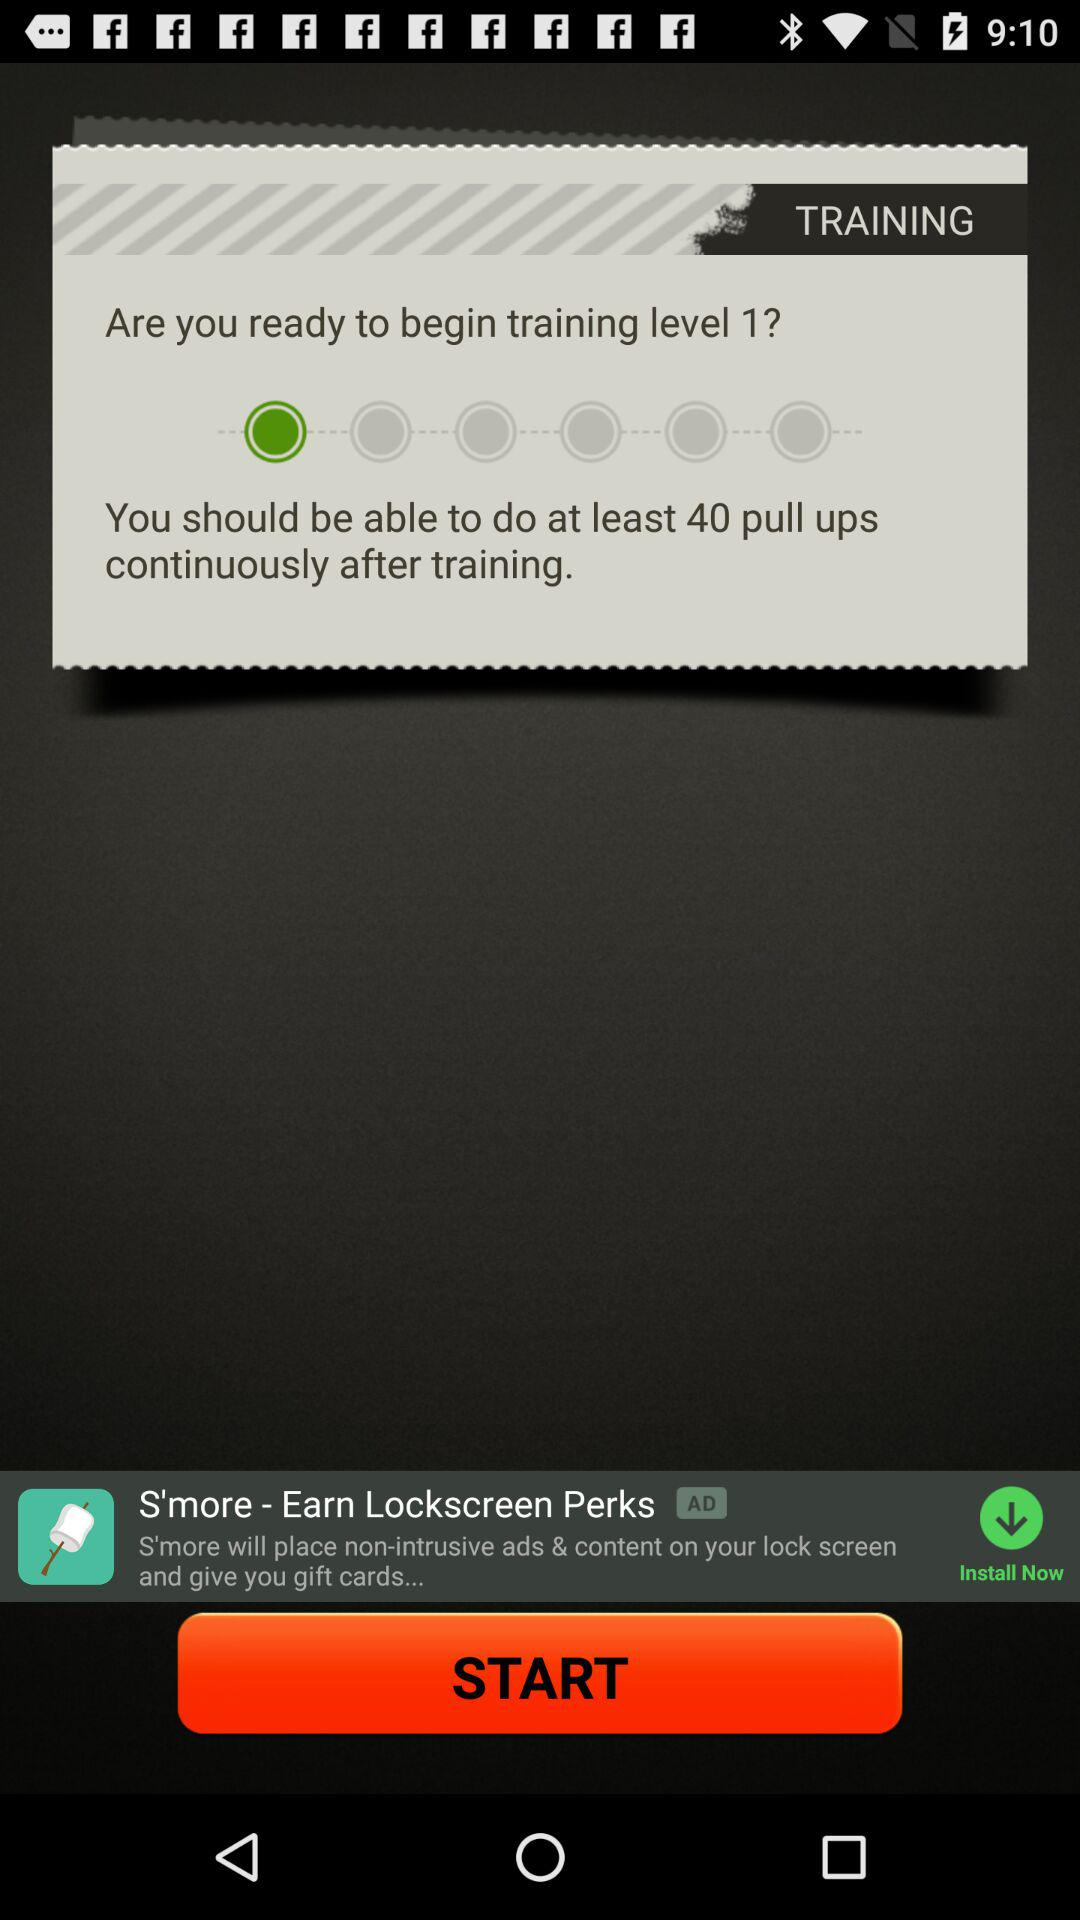What is the name of the application?
When the provided information is insufficient, respond with <no answer>. <no answer> 